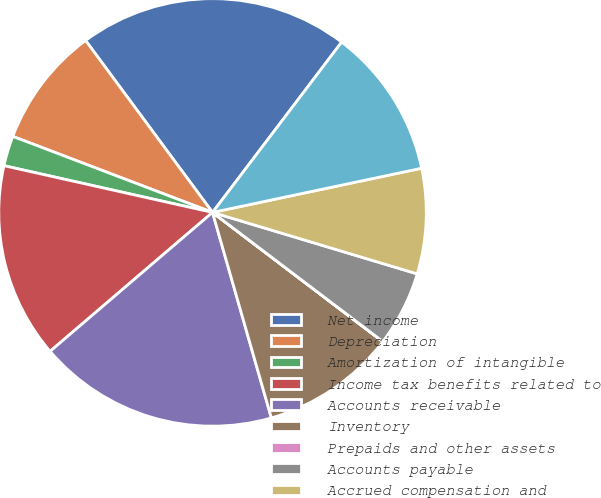Convert chart to OTSL. <chart><loc_0><loc_0><loc_500><loc_500><pie_chart><fcel>Net income<fcel>Depreciation<fcel>Amortization of intangible<fcel>Income tax benefits related to<fcel>Accounts receivable<fcel>Inventory<fcel>Prepaids and other assets<fcel>Accounts payable<fcel>Accrued compensation and<fcel>Deferred revenue<nl><fcel>20.45%<fcel>9.09%<fcel>2.28%<fcel>14.77%<fcel>18.18%<fcel>10.23%<fcel>0.01%<fcel>5.68%<fcel>7.96%<fcel>11.36%<nl></chart> 